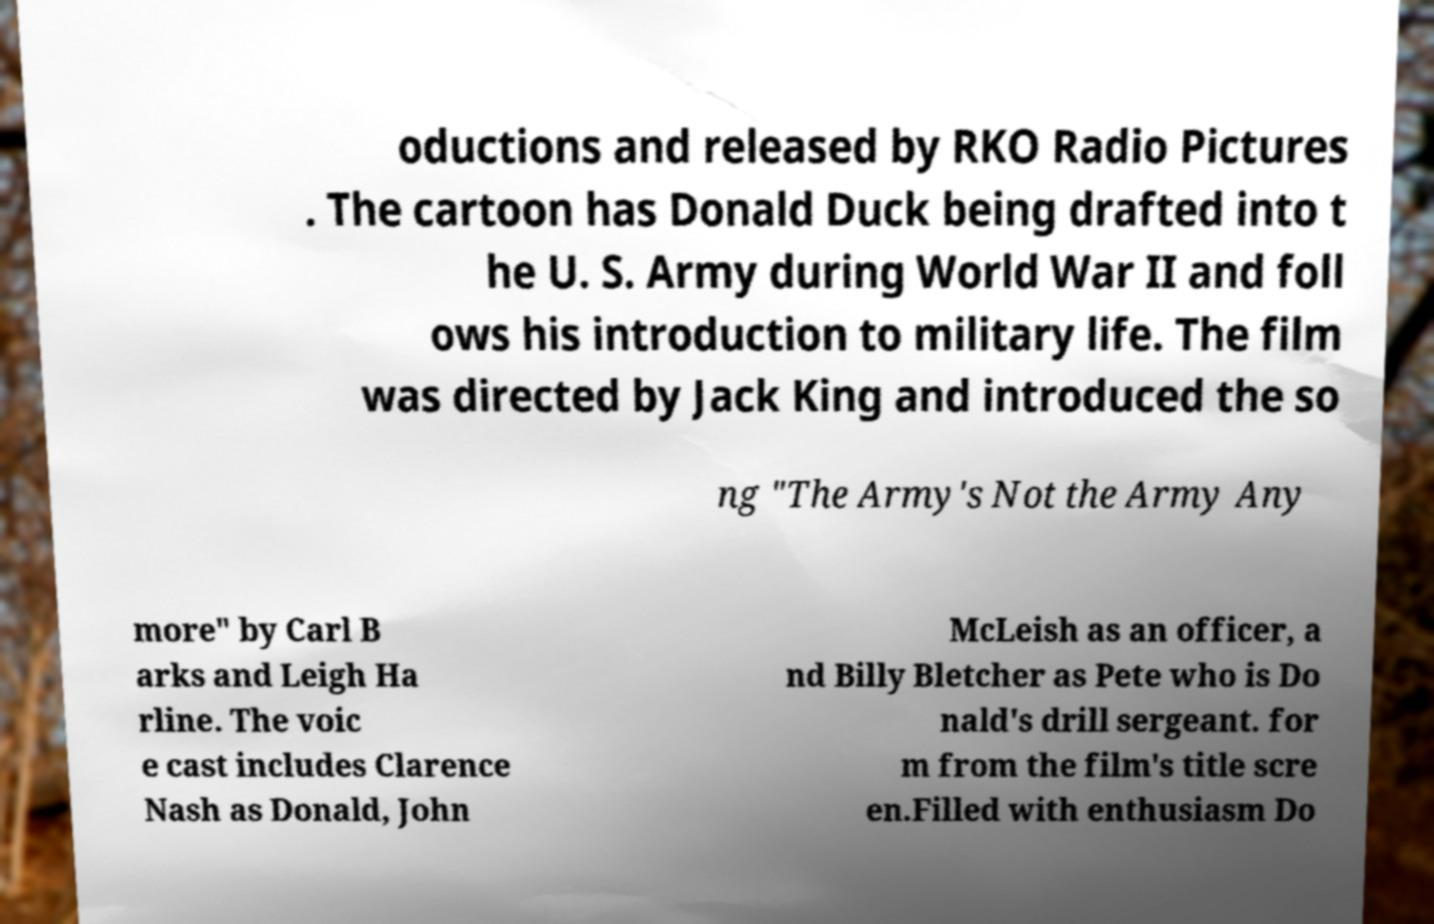Please identify and transcribe the text found in this image. oductions and released by RKO Radio Pictures . The cartoon has Donald Duck being drafted into t he U. S. Army during World War II and foll ows his introduction to military life. The film was directed by Jack King and introduced the so ng "The Army's Not the Army Any more" by Carl B arks and Leigh Ha rline. The voic e cast includes Clarence Nash as Donald, John McLeish as an officer, a nd Billy Bletcher as Pete who is Do nald's drill sergeant. for m from the film's title scre en.Filled with enthusiasm Do 